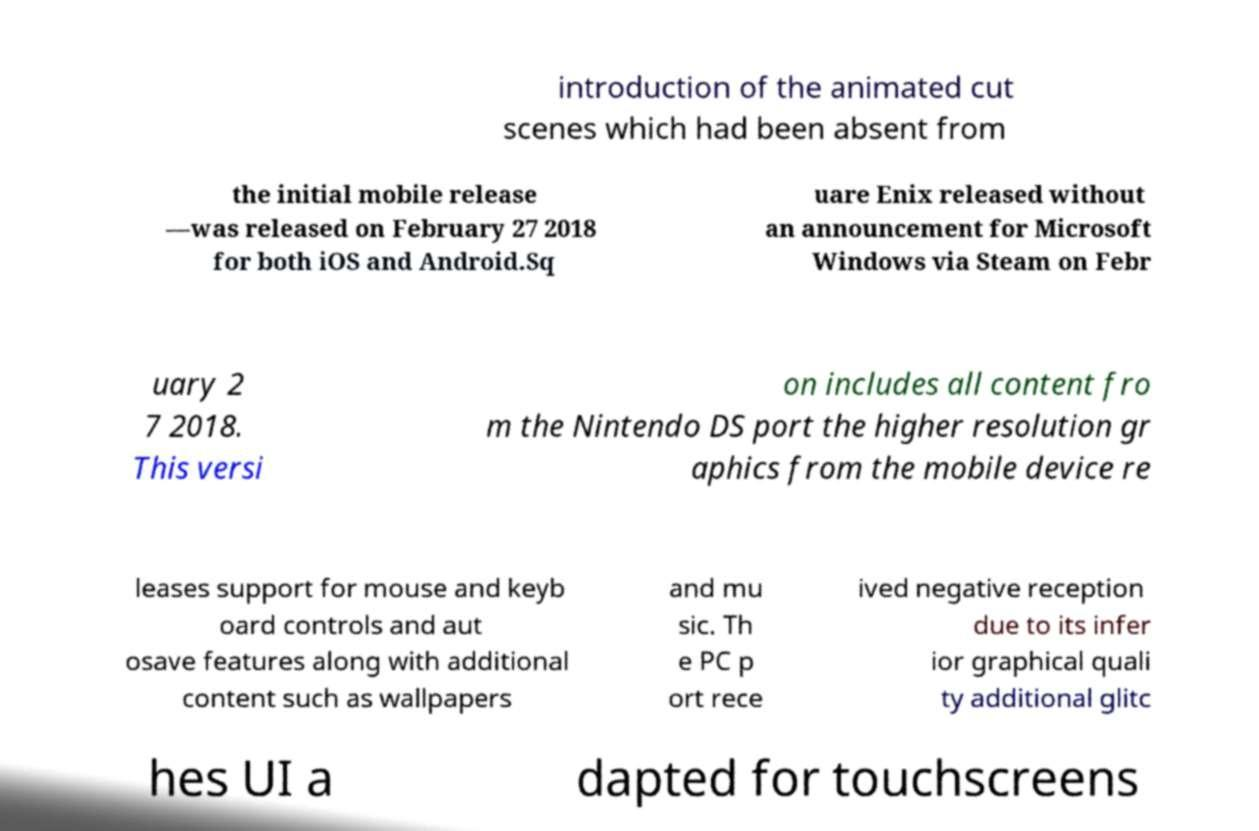Please read and relay the text visible in this image. What does it say? introduction of the animated cut scenes which had been absent from the initial mobile release —was released on February 27 2018 for both iOS and Android.Sq uare Enix released without an announcement for Microsoft Windows via Steam on Febr uary 2 7 2018. This versi on includes all content fro m the Nintendo DS port the higher resolution gr aphics from the mobile device re leases support for mouse and keyb oard controls and aut osave features along with additional content such as wallpapers and mu sic. Th e PC p ort rece ived negative reception due to its infer ior graphical quali ty additional glitc hes UI a dapted for touchscreens 